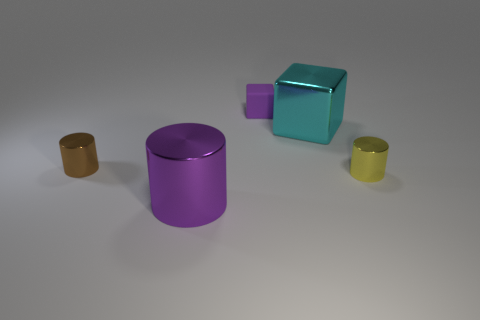Subtract all big shiny cylinders. How many cylinders are left? 2 Add 4 rubber blocks. How many objects exist? 9 Subtract all red cylinders. Subtract all red balls. How many cylinders are left? 3 Subtract all cylinders. How many objects are left? 2 Add 4 tiny yellow shiny things. How many tiny yellow shiny things are left? 5 Add 1 large purple metallic cylinders. How many large purple metallic cylinders exist? 2 Subtract 0 purple balls. How many objects are left? 5 Subtract all metallic things. Subtract all purple metal cylinders. How many objects are left? 0 